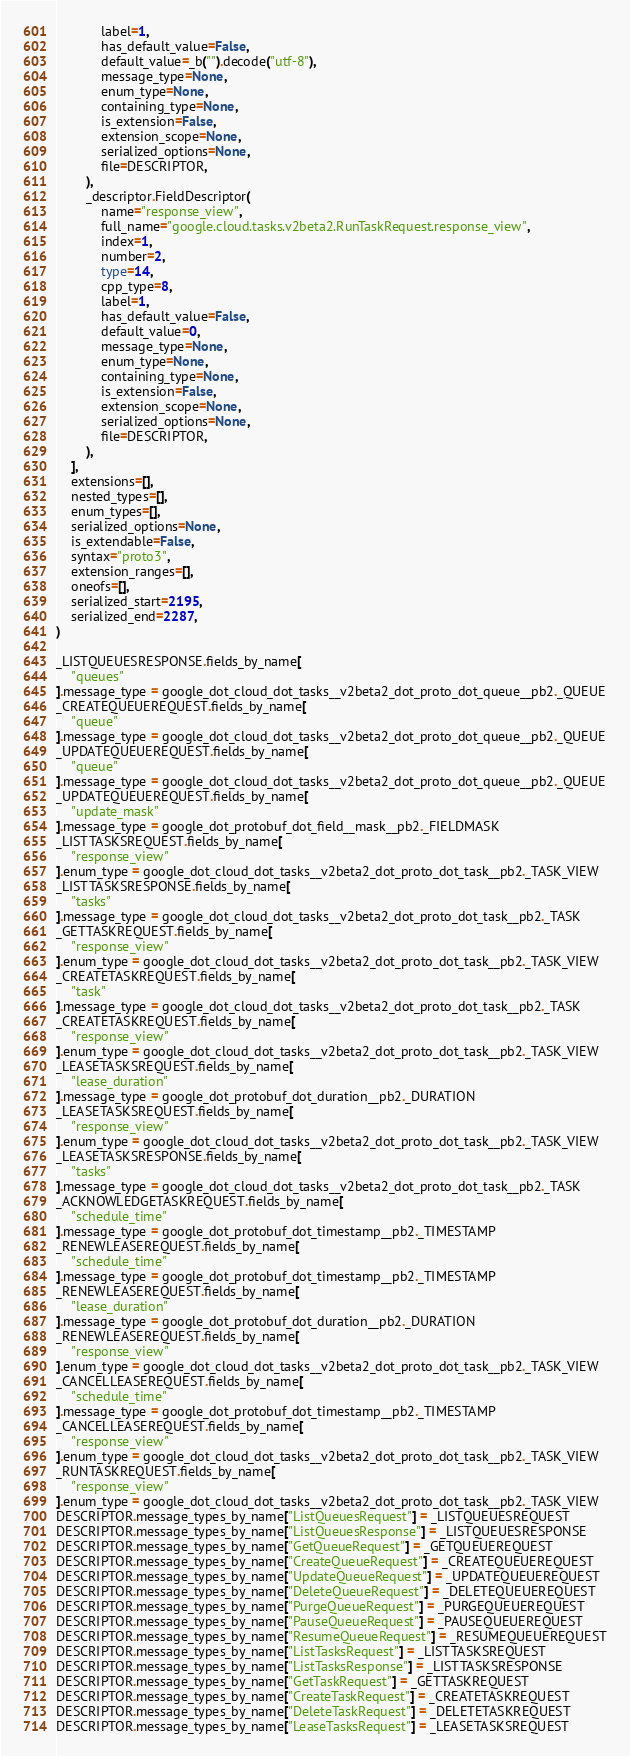Convert code to text. <code><loc_0><loc_0><loc_500><loc_500><_Python_>            label=1,
            has_default_value=False,
            default_value=_b("").decode("utf-8"),
            message_type=None,
            enum_type=None,
            containing_type=None,
            is_extension=False,
            extension_scope=None,
            serialized_options=None,
            file=DESCRIPTOR,
        ),
        _descriptor.FieldDescriptor(
            name="response_view",
            full_name="google.cloud.tasks.v2beta2.RunTaskRequest.response_view",
            index=1,
            number=2,
            type=14,
            cpp_type=8,
            label=1,
            has_default_value=False,
            default_value=0,
            message_type=None,
            enum_type=None,
            containing_type=None,
            is_extension=False,
            extension_scope=None,
            serialized_options=None,
            file=DESCRIPTOR,
        ),
    ],
    extensions=[],
    nested_types=[],
    enum_types=[],
    serialized_options=None,
    is_extendable=False,
    syntax="proto3",
    extension_ranges=[],
    oneofs=[],
    serialized_start=2195,
    serialized_end=2287,
)

_LISTQUEUESRESPONSE.fields_by_name[
    "queues"
].message_type = google_dot_cloud_dot_tasks__v2beta2_dot_proto_dot_queue__pb2._QUEUE
_CREATEQUEUEREQUEST.fields_by_name[
    "queue"
].message_type = google_dot_cloud_dot_tasks__v2beta2_dot_proto_dot_queue__pb2._QUEUE
_UPDATEQUEUEREQUEST.fields_by_name[
    "queue"
].message_type = google_dot_cloud_dot_tasks__v2beta2_dot_proto_dot_queue__pb2._QUEUE
_UPDATEQUEUEREQUEST.fields_by_name[
    "update_mask"
].message_type = google_dot_protobuf_dot_field__mask__pb2._FIELDMASK
_LISTTASKSREQUEST.fields_by_name[
    "response_view"
].enum_type = google_dot_cloud_dot_tasks__v2beta2_dot_proto_dot_task__pb2._TASK_VIEW
_LISTTASKSRESPONSE.fields_by_name[
    "tasks"
].message_type = google_dot_cloud_dot_tasks__v2beta2_dot_proto_dot_task__pb2._TASK
_GETTASKREQUEST.fields_by_name[
    "response_view"
].enum_type = google_dot_cloud_dot_tasks__v2beta2_dot_proto_dot_task__pb2._TASK_VIEW
_CREATETASKREQUEST.fields_by_name[
    "task"
].message_type = google_dot_cloud_dot_tasks__v2beta2_dot_proto_dot_task__pb2._TASK
_CREATETASKREQUEST.fields_by_name[
    "response_view"
].enum_type = google_dot_cloud_dot_tasks__v2beta2_dot_proto_dot_task__pb2._TASK_VIEW
_LEASETASKSREQUEST.fields_by_name[
    "lease_duration"
].message_type = google_dot_protobuf_dot_duration__pb2._DURATION
_LEASETASKSREQUEST.fields_by_name[
    "response_view"
].enum_type = google_dot_cloud_dot_tasks__v2beta2_dot_proto_dot_task__pb2._TASK_VIEW
_LEASETASKSRESPONSE.fields_by_name[
    "tasks"
].message_type = google_dot_cloud_dot_tasks__v2beta2_dot_proto_dot_task__pb2._TASK
_ACKNOWLEDGETASKREQUEST.fields_by_name[
    "schedule_time"
].message_type = google_dot_protobuf_dot_timestamp__pb2._TIMESTAMP
_RENEWLEASEREQUEST.fields_by_name[
    "schedule_time"
].message_type = google_dot_protobuf_dot_timestamp__pb2._TIMESTAMP
_RENEWLEASEREQUEST.fields_by_name[
    "lease_duration"
].message_type = google_dot_protobuf_dot_duration__pb2._DURATION
_RENEWLEASEREQUEST.fields_by_name[
    "response_view"
].enum_type = google_dot_cloud_dot_tasks__v2beta2_dot_proto_dot_task__pb2._TASK_VIEW
_CANCELLEASEREQUEST.fields_by_name[
    "schedule_time"
].message_type = google_dot_protobuf_dot_timestamp__pb2._TIMESTAMP
_CANCELLEASEREQUEST.fields_by_name[
    "response_view"
].enum_type = google_dot_cloud_dot_tasks__v2beta2_dot_proto_dot_task__pb2._TASK_VIEW
_RUNTASKREQUEST.fields_by_name[
    "response_view"
].enum_type = google_dot_cloud_dot_tasks__v2beta2_dot_proto_dot_task__pb2._TASK_VIEW
DESCRIPTOR.message_types_by_name["ListQueuesRequest"] = _LISTQUEUESREQUEST
DESCRIPTOR.message_types_by_name["ListQueuesResponse"] = _LISTQUEUESRESPONSE
DESCRIPTOR.message_types_by_name["GetQueueRequest"] = _GETQUEUEREQUEST
DESCRIPTOR.message_types_by_name["CreateQueueRequest"] = _CREATEQUEUEREQUEST
DESCRIPTOR.message_types_by_name["UpdateQueueRequest"] = _UPDATEQUEUEREQUEST
DESCRIPTOR.message_types_by_name["DeleteQueueRequest"] = _DELETEQUEUEREQUEST
DESCRIPTOR.message_types_by_name["PurgeQueueRequest"] = _PURGEQUEUEREQUEST
DESCRIPTOR.message_types_by_name["PauseQueueRequest"] = _PAUSEQUEUEREQUEST
DESCRIPTOR.message_types_by_name["ResumeQueueRequest"] = _RESUMEQUEUEREQUEST
DESCRIPTOR.message_types_by_name["ListTasksRequest"] = _LISTTASKSREQUEST
DESCRIPTOR.message_types_by_name["ListTasksResponse"] = _LISTTASKSRESPONSE
DESCRIPTOR.message_types_by_name["GetTaskRequest"] = _GETTASKREQUEST
DESCRIPTOR.message_types_by_name["CreateTaskRequest"] = _CREATETASKREQUEST
DESCRIPTOR.message_types_by_name["DeleteTaskRequest"] = _DELETETASKREQUEST
DESCRIPTOR.message_types_by_name["LeaseTasksRequest"] = _LEASETASKSREQUEST</code> 